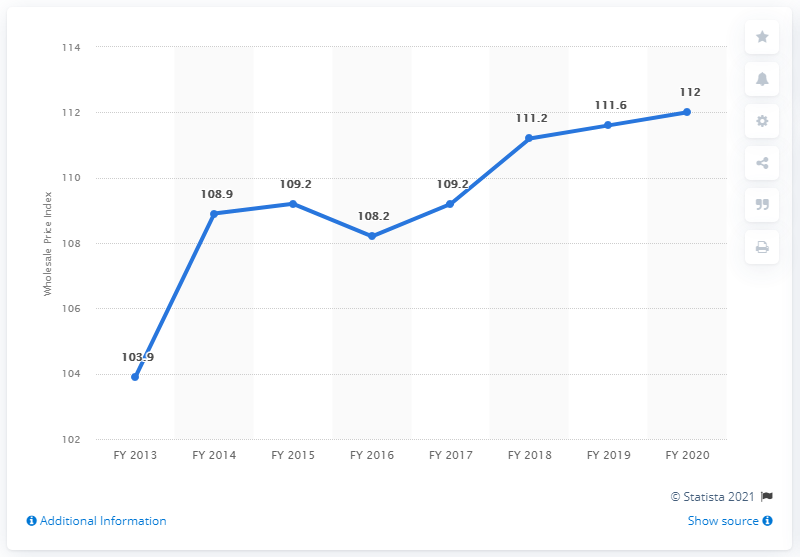Outline some significant characteristics in this image. The wholesale price index of electrical equipment in FY 2017 was not higher than in FY 2018. The wholesale price index of electrical equipment in the financial year 2015 was 109.2. 